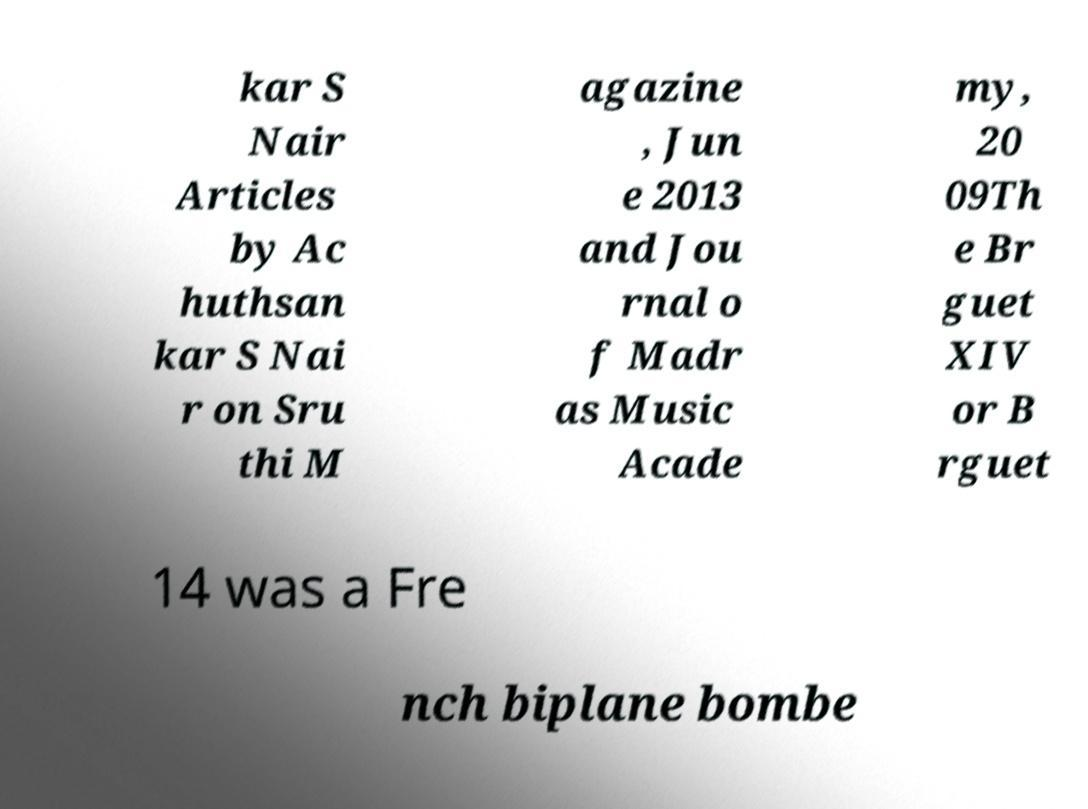For documentation purposes, I need the text within this image transcribed. Could you provide that? kar S Nair Articles by Ac huthsan kar S Nai r on Sru thi M agazine , Jun e 2013 and Jou rnal o f Madr as Music Acade my, 20 09Th e Br guet XIV or B rguet 14 was a Fre nch biplane bombe 